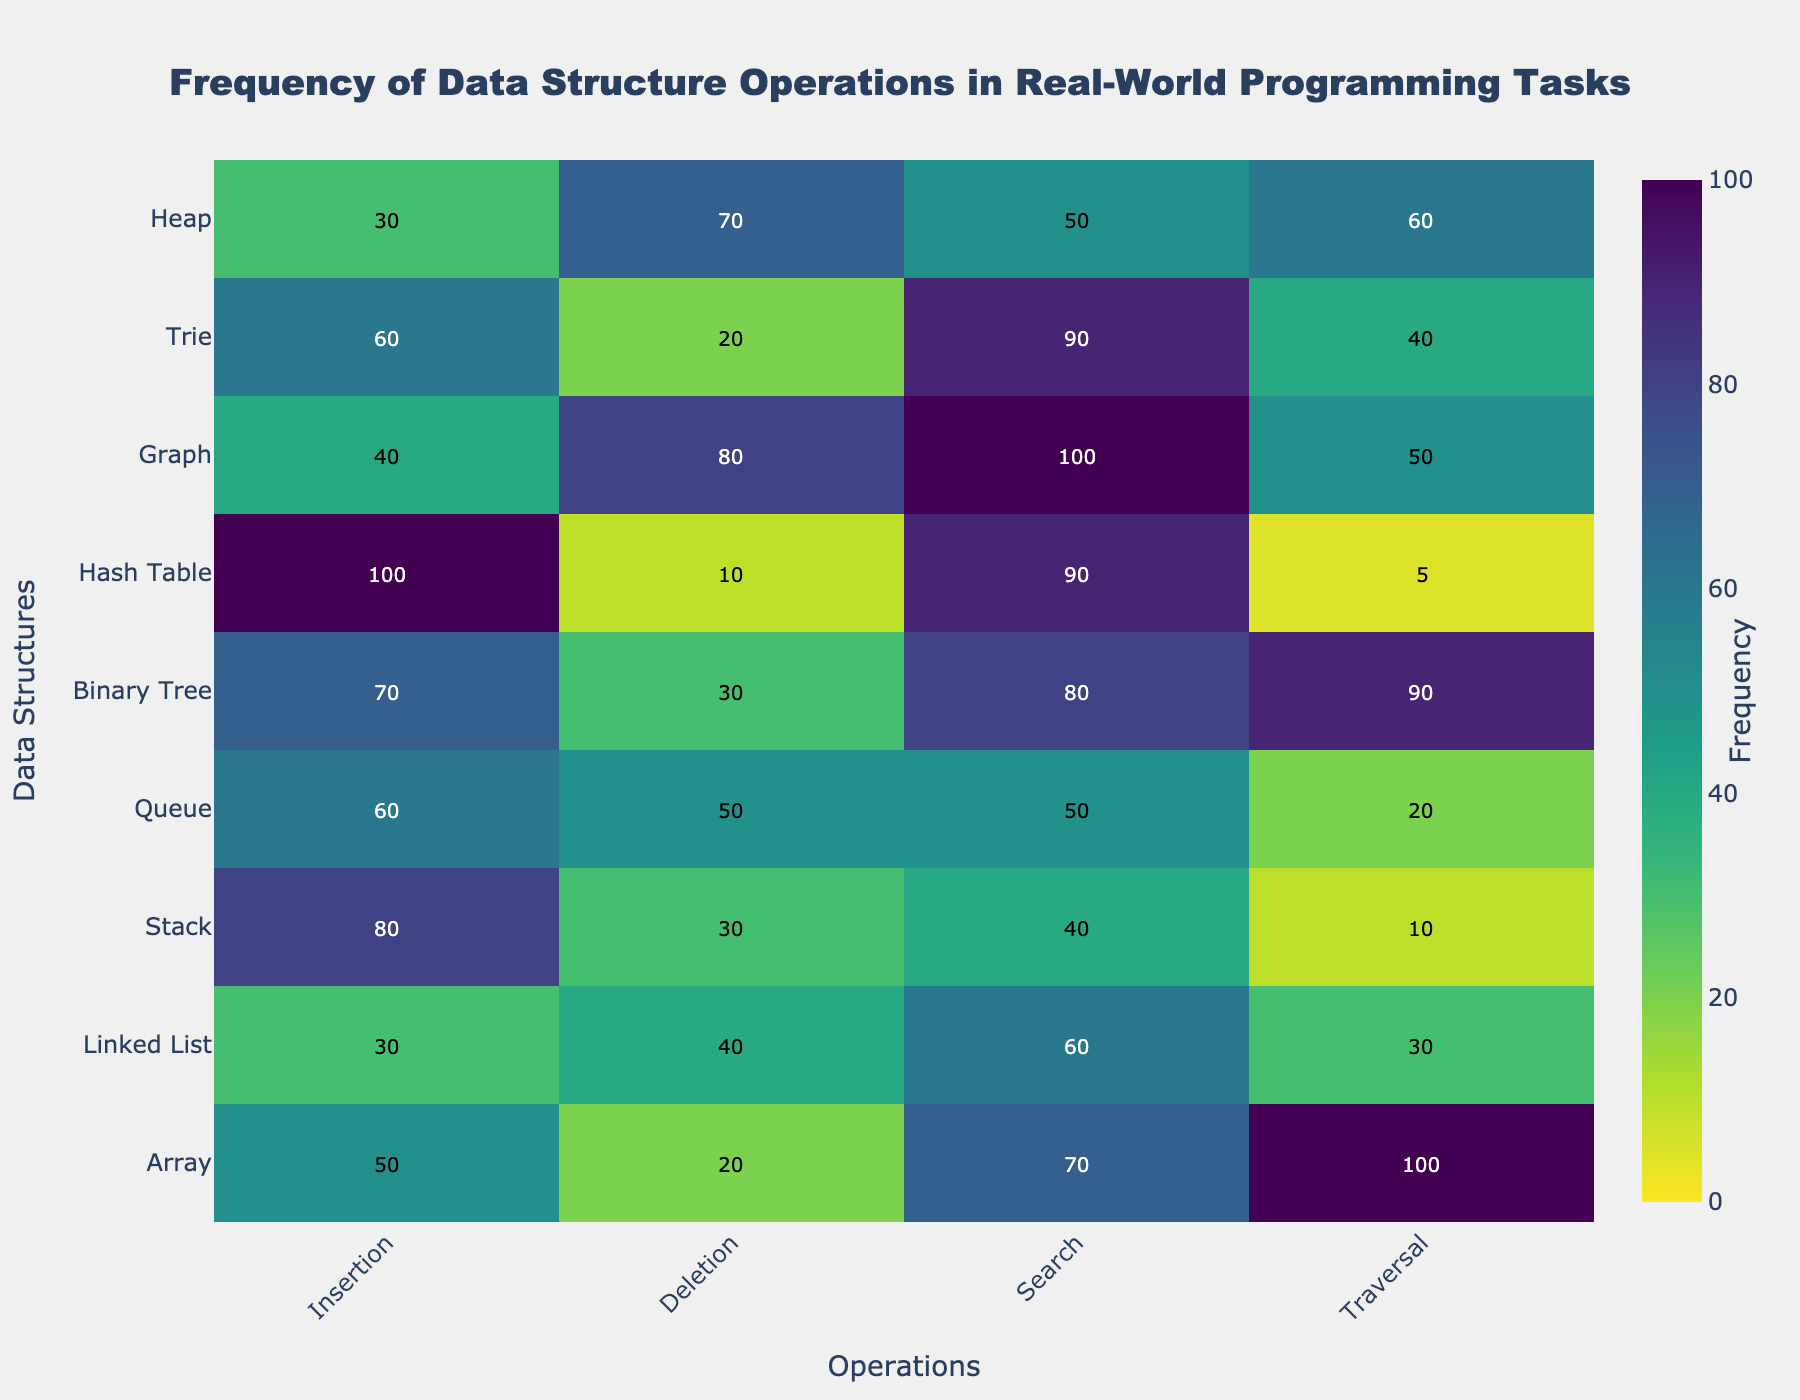What's the title of the figure? The title is generally located at the top of the figure. In this case, the title displayed is "Frequency of Data Structure Operations in Real-World Programming Tasks".
Answer: Frequency of Data Structure Operations in Real-World Programming Tasks Which data structure has the highest frequency for insertion? The heatmap displays the frequency for each operation (Insertion, Deletion, Search, Traversal) across different data structures. The highest value in the Insertion column is 100 for the Hash Table.
Answer: Hash Table Which operation has the lowest frequency for the Binary Tree? By looking at the row for Binary Tree, the operation with the lowest frequency can be spotted. The lowest value is 30, which corresponds to the Deletion operation.
Answer: Deletion What is the frequency range depicted in the colorbar? The colorbar shows the range of frequencies represented by different colors on the heatmap. The minimum value is 0, and the maximum value is 100.
Answer: 0 to 100 What are the common frequencies (above 50) for the Graph data structure? By examining the row for the Graph data structure, we see the frequencies are Insertion: 40, Deletion: 80, Search: 100, and Traversal: 50. The frequencies above 50 are Deletion (80) and Search (100).
Answer: Deletion, Search Which data structure has the most balanced (similar) frequencies for all operations? To determine this, we compare the values for each data structure row to see which data structure has the least variability. By visual inspection, the Linked List (Insertion: 30, Deletion: 40, Search: 60, Traversal: 30) has relatively balanced frequencies.
Answer: Linked List Which operation has the most variation in frequencies across data structures? Variation can be measured by the range or the standard deviation of the values in each column. In this case, by visual inspection, the Search operation varies widely with 40 (Stack) to 100 (Array, Graph).
Answer: Search What's the total frequency of traversal operations across all data structures? Summing up all the values in the Traversal column (100, 30, 10, 20, 90, 5, 50, 40, 60) yields the total frequency: 100 + 30 + 10 + 20 + 90 + 5 + 50 + 40 + 60 = 405.
Answer: 405 How do Array and Hash Table compare in terms of search frequency? Checking the Search values for both Array (70) and Hash Table (90) shows that Hash Table has a higher frequency.
Answer: Hash Table has a higher search frequency Which operation is performed least frequently across all data structures? To determine this, review the entire heatmap and find the minimum value, which is 5 for Hash Table Traversal.
Answer: Hash Table Traversal (5) 